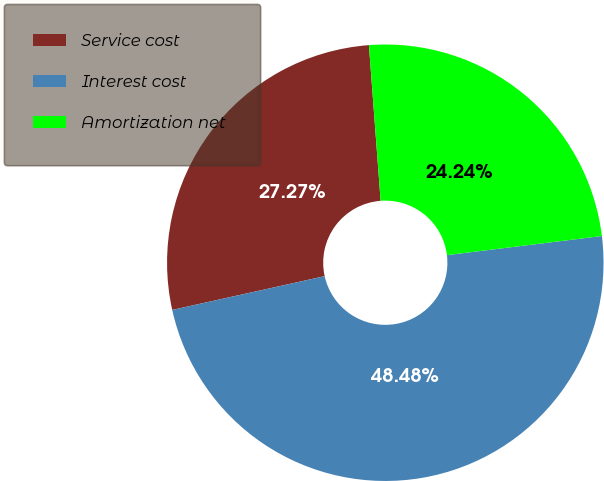Convert chart to OTSL. <chart><loc_0><loc_0><loc_500><loc_500><pie_chart><fcel>Service cost<fcel>Interest cost<fcel>Amortization net<nl><fcel>27.27%<fcel>48.48%<fcel>24.24%<nl></chart> 